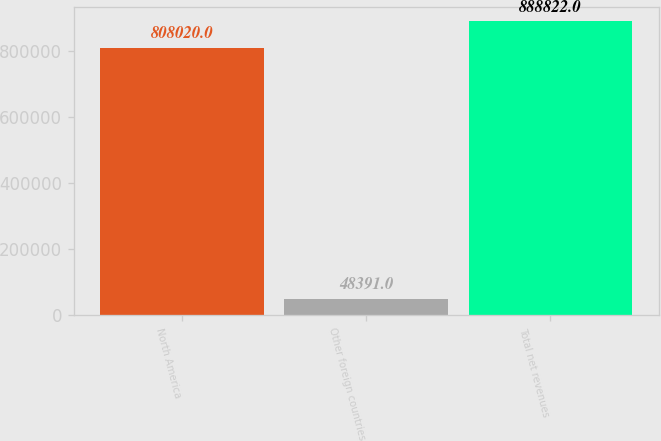Convert chart to OTSL. <chart><loc_0><loc_0><loc_500><loc_500><bar_chart><fcel>North America<fcel>Other foreign countries<fcel>Total net revenues<nl><fcel>808020<fcel>48391<fcel>888822<nl></chart> 